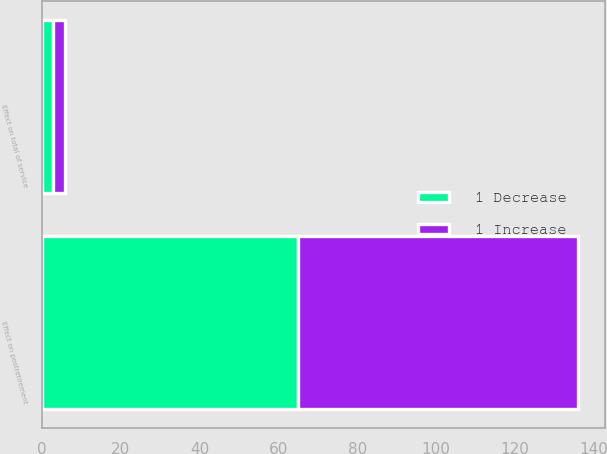Convert chart to OTSL. <chart><loc_0><loc_0><loc_500><loc_500><stacked_bar_chart><ecel><fcel>Effect on total of service<fcel>Effect on postretirement<nl><fcel>1 Decrease<fcel>3<fcel>65<nl><fcel>1 Increase<fcel>3<fcel>71<nl></chart> 